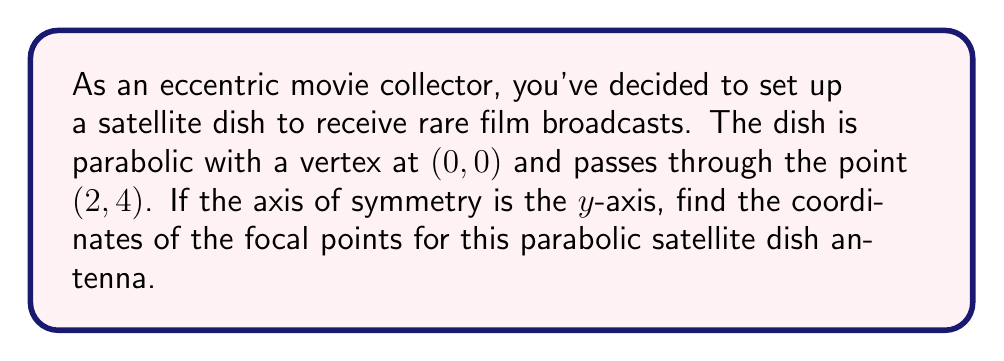Could you help me with this problem? Let's approach this step-by-step:

1) The general equation of a parabola with vertex at the origin and y-axis as the axis of symmetry is:

   $$y = ax^2$$

2) We know the parabola passes through the point (2, 4). Let's substitute this into our equation:

   $$4 = a(2)^2$$
   $$4 = 4a$$
   $$a = 1$$

3) So, our parabola equation is:

   $$y = x^2$$

4) For a parabola in this form, the focal length (distance from vertex to focus) is given by:

   $$f = \frac{1}{4a}$$

5) Substituting our value of $a$:

   $$f = \frac{1}{4(1)} = \frac{1}{4}$$

6) Since the axis of symmetry is the y-axis, the focus will be on the y-axis, $\frac{1}{4}$ units above the vertex.

7) Therefore, the coordinates of the focal point are:

   $$(0, \frac{1}{4})$$

[asy]
import graph;
size(200);
real f(real x) {return x^2;}
draw(graph(f,-3,3));
dot((0,0.25),red);
dot((0,0));
dot((2,4));
label("(0,0)",(0,0),SW);
label("(2,4)",(2,4),NE);
label("F(0,1/4)",(0,0.25),NE);
[/asy]
Answer: $(0, \frac{1}{4})$ 